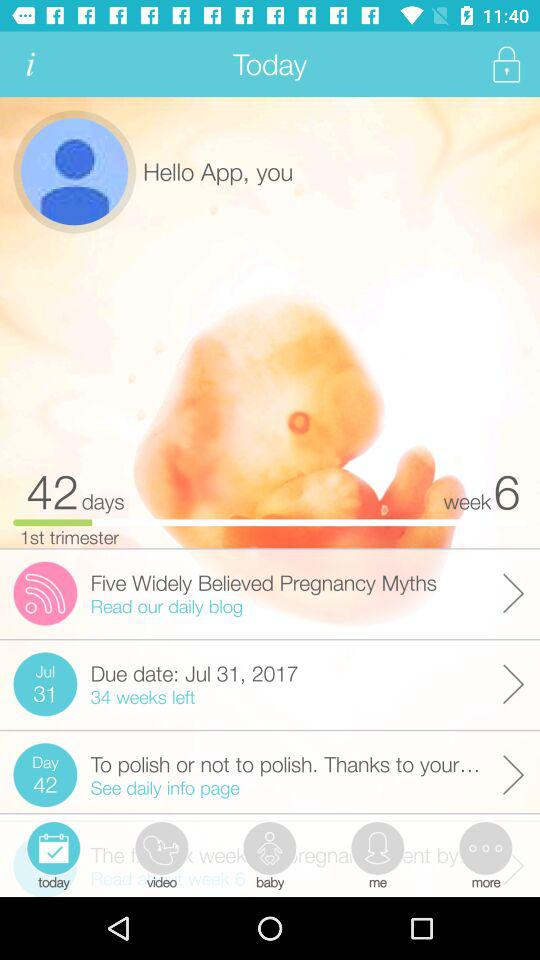What is the due date? The due date is July 31, 2017. 